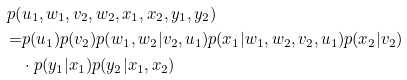<formula> <loc_0><loc_0><loc_500><loc_500>p ( & u _ { 1 } , w _ { 1 } , v _ { 2 } , w _ { 2 } , x _ { 1 } , x _ { 2 } , y _ { 1 } , y _ { 2 } ) \\ = & p ( u _ { 1 } ) p ( v _ { 2 } ) p ( w _ { 1 } , w _ { 2 } | v _ { 2 } , u _ { 1 } ) p ( x _ { 1 } | w _ { 1 } , w _ { 2 } , v _ { 2 } , u _ { 1 } ) p ( x _ { 2 } | v _ { 2 } ) \\ & \cdot p ( y _ { 1 } | x _ { 1 } ) p ( y _ { 2 } | x _ { 1 } , x _ { 2 } )</formula> 